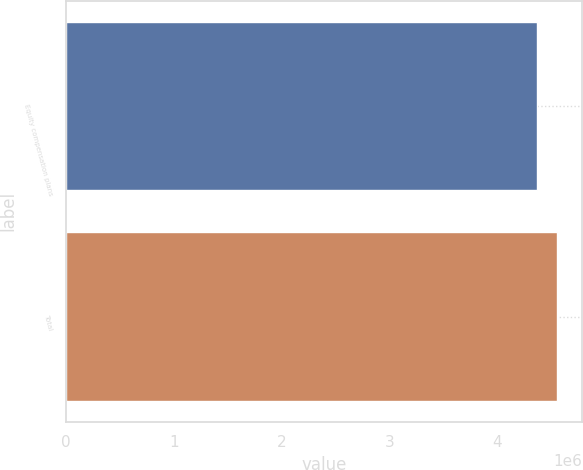Convert chart. <chart><loc_0><loc_0><loc_500><loc_500><bar_chart><fcel>Equity compensation plans<fcel>Total<nl><fcel>4.36184e+06<fcel>4.55498e+06<nl></chart> 